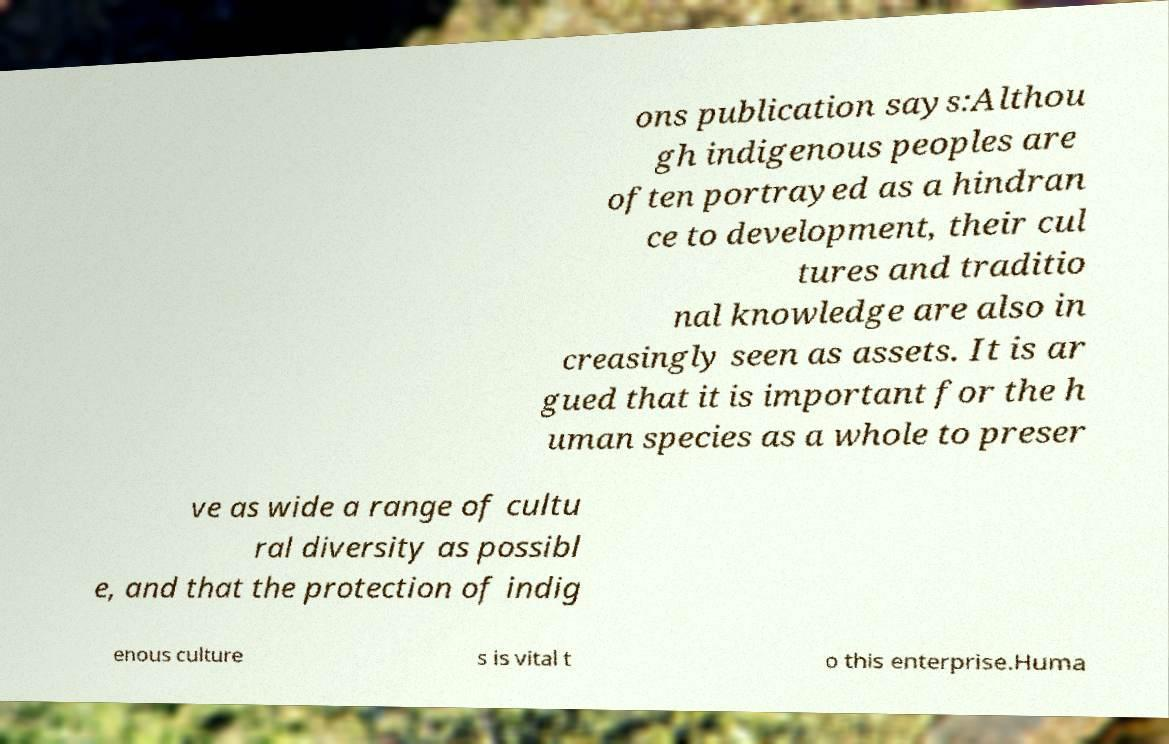Could you assist in decoding the text presented in this image and type it out clearly? ons publication says:Althou gh indigenous peoples are often portrayed as a hindran ce to development, their cul tures and traditio nal knowledge are also in creasingly seen as assets. It is ar gued that it is important for the h uman species as a whole to preser ve as wide a range of cultu ral diversity as possibl e, and that the protection of indig enous culture s is vital t o this enterprise.Huma 